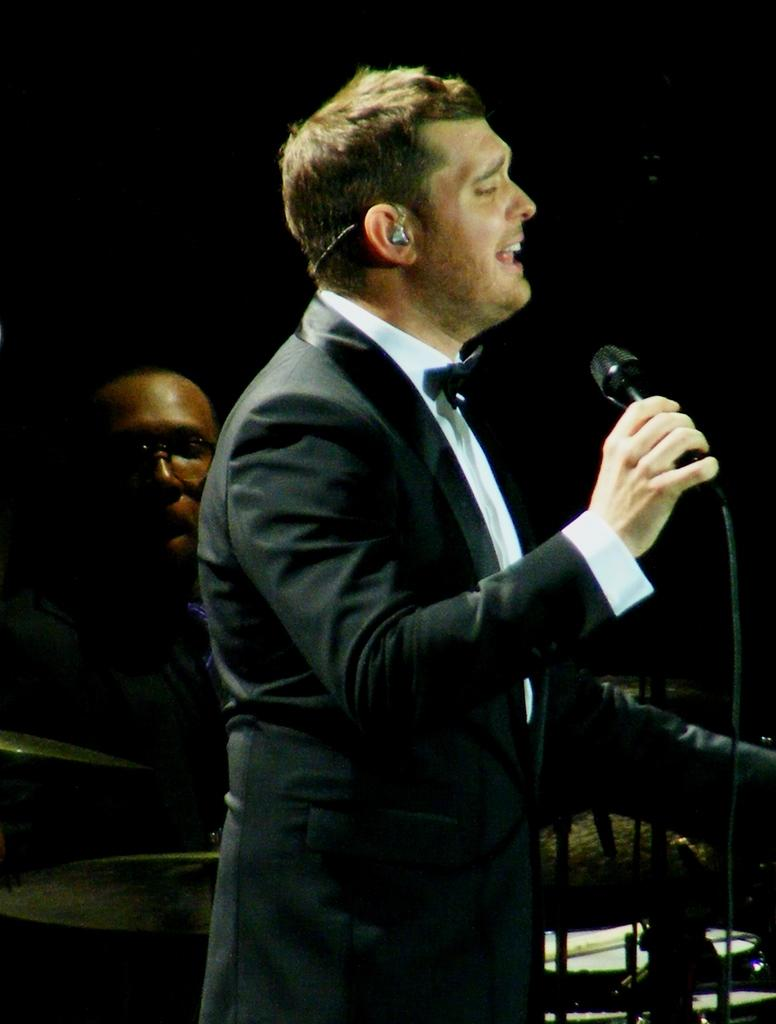How many people are present in the image? There are two people in the image. What are the two people doing in the image? One person is singing with the help of a microphone, and another person is playing drums. What type of fan can be seen in the image? There is no fan present in the image. What year does the image depict? The image does not depict a specific year; it is a snapshot of a musical performance. 